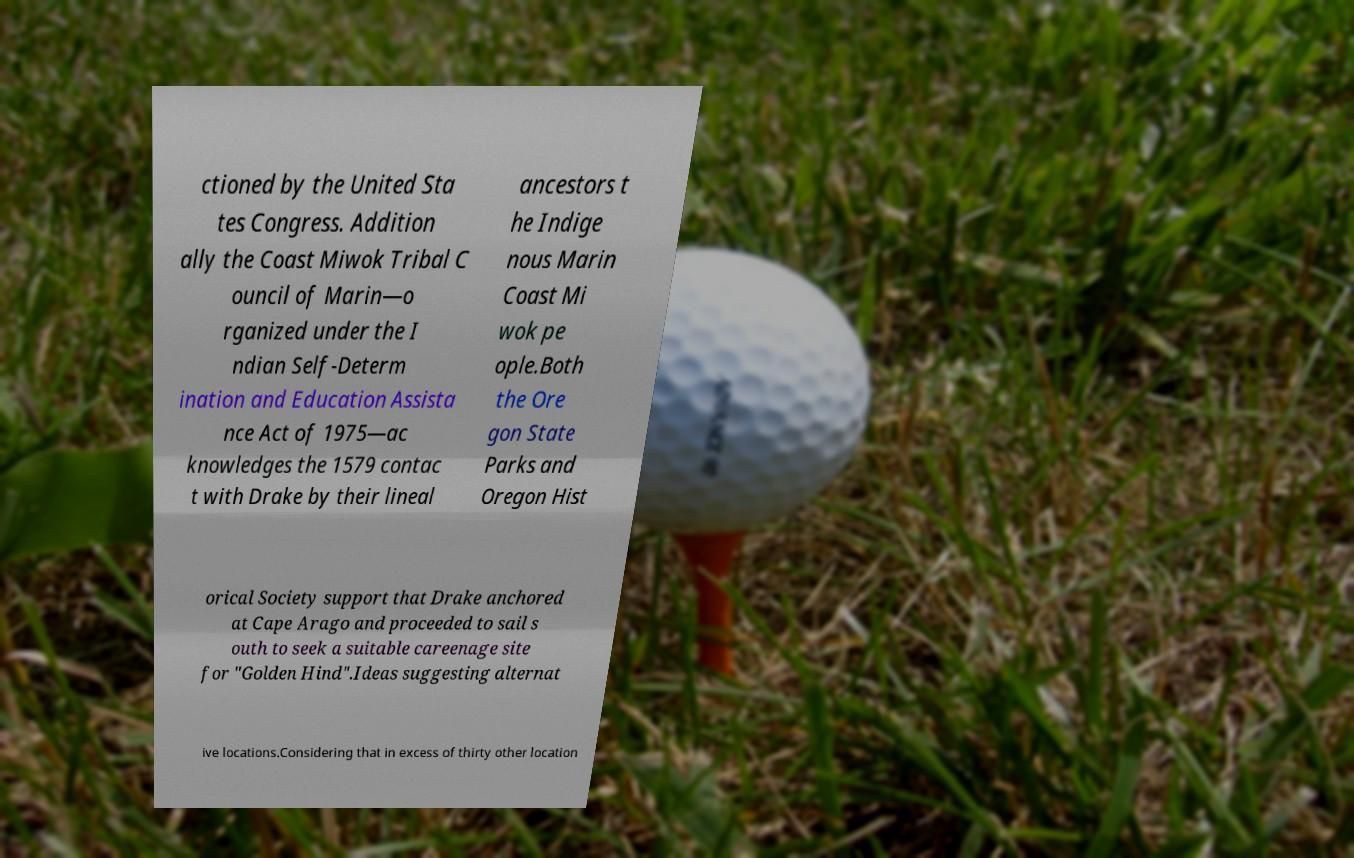What messages or text are displayed in this image? I need them in a readable, typed format. ctioned by the United Sta tes Congress. Addition ally the Coast Miwok Tribal C ouncil of Marin—o rganized under the I ndian Self-Determ ination and Education Assista nce Act of 1975—ac knowledges the 1579 contac t with Drake by their lineal ancestors t he Indige nous Marin Coast Mi wok pe ople.Both the Ore gon State Parks and Oregon Hist orical Society support that Drake anchored at Cape Arago and proceeded to sail s outh to seek a suitable careenage site for "Golden Hind".Ideas suggesting alternat ive locations.Considering that in excess of thirty other location 